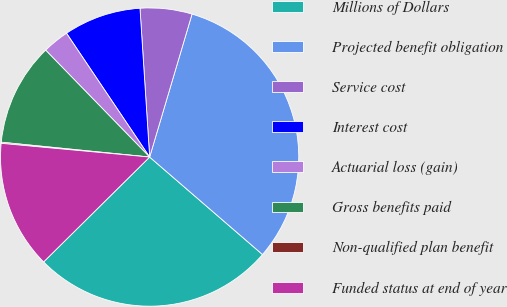Convert chart. <chart><loc_0><loc_0><loc_500><loc_500><pie_chart><fcel>Millions of Dollars<fcel>Projected benefit obligation<fcel>Service cost<fcel>Interest cost<fcel>Actuarial loss (gain)<fcel>Gross benefits paid<fcel>Non-qualified plan benefit<fcel>Funded status at end of year<nl><fcel>26.25%<fcel>31.75%<fcel>5.62%<fcel>8.38%<fcel>2.87%<fcel>11.13%<fcel>0.12%<fcel>13.88%<nl></chart> 